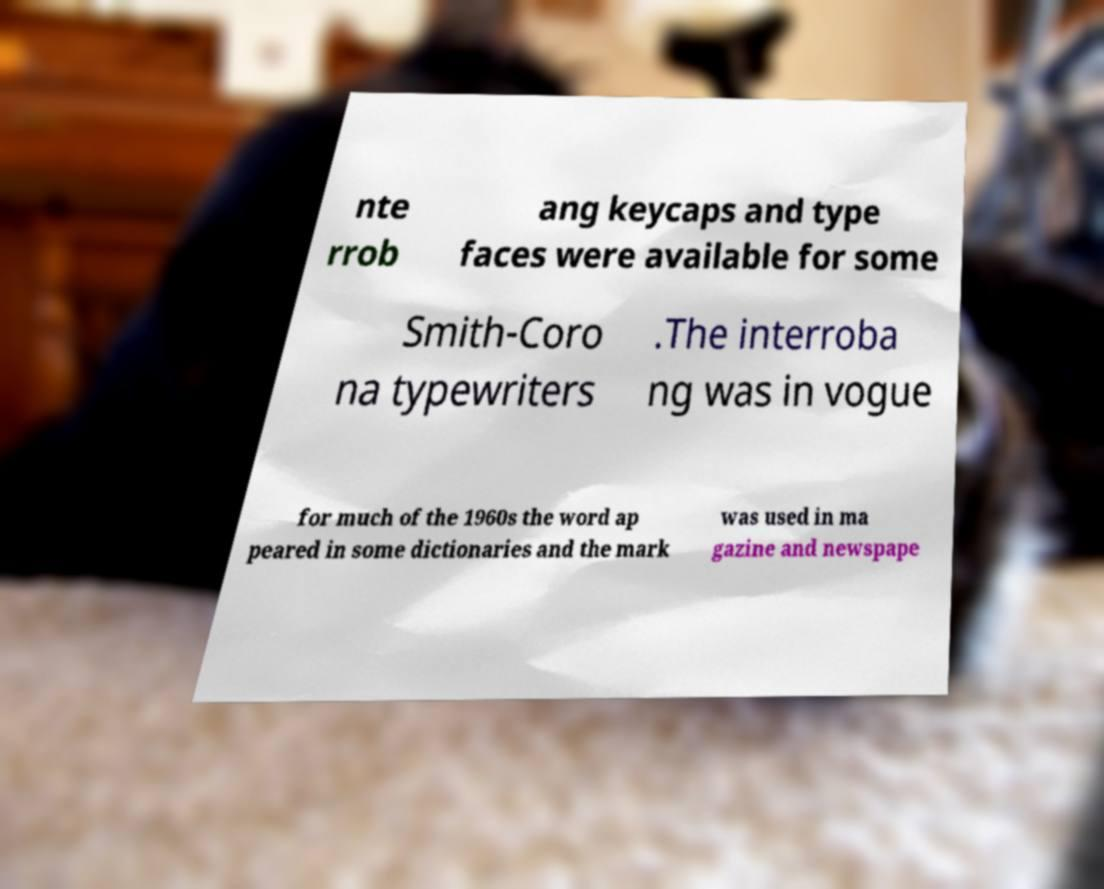Please read and relay the text visible in this image. What does it say? nte rrob ang keycaps and type faces were available for some Smith-Coro na typewriters .The interroba ng was in vogue for much of the 1960s the word ap peared in some dictionaries and the mark was used in ma gazine and newspape 